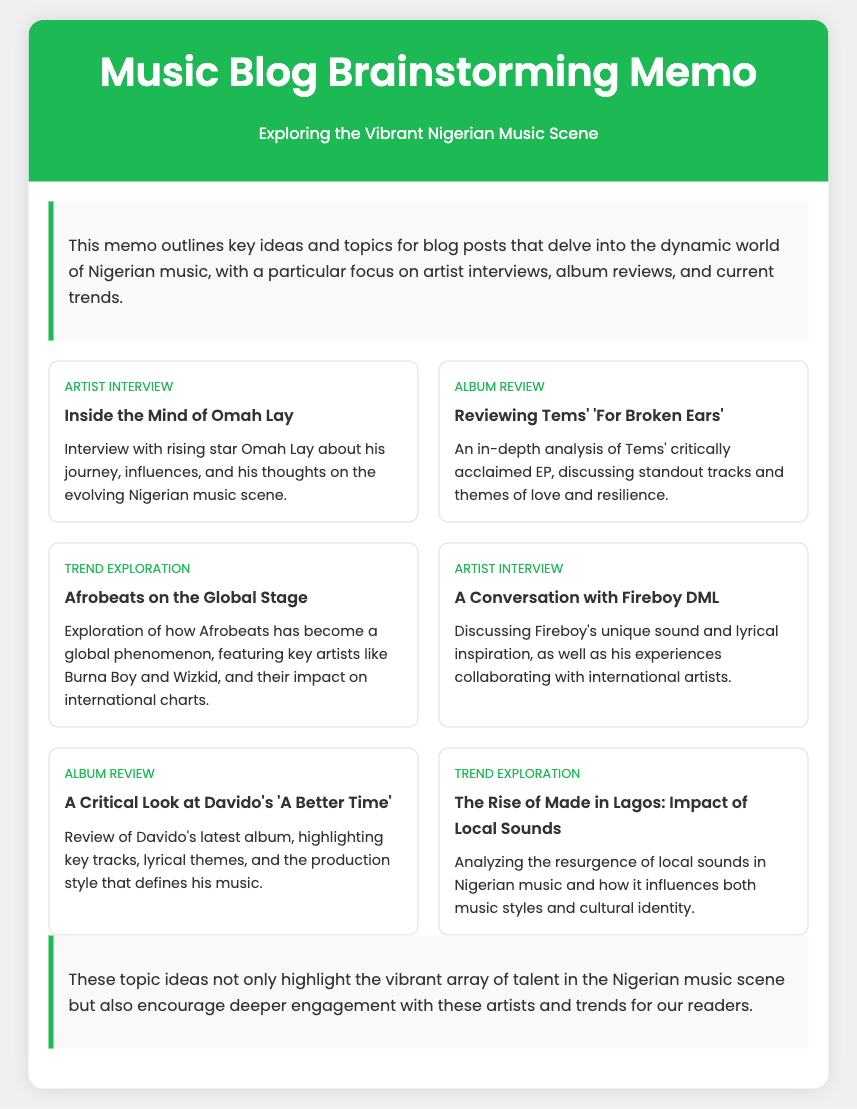What is the title of the memo? The title of the memo is located in the header section and outlines the purpose of the document.
Answer: Music Blog Brainstorming Memo Who is the artist featured in the first interview idea? The first interview idea specifies the artist's name and highlights his journey in Nigerian music.
Answer: Omah Lay What is the title of Tems’ EP mentioned in the album review? The album review discusses a specific work by Tems and provides its title for reference.
Answer: For Broken Ears What genre is being explored in the trend titled "Afrobeats on the Global Stage"? The trend exploration section highlights a specific genre's international presence and significance.
Answer: Afrobeats How many album reviews are included in the ideas? The document lists the number of album reviews as part of a structured idea list, which contributes to the overall content.
Answer: 2 